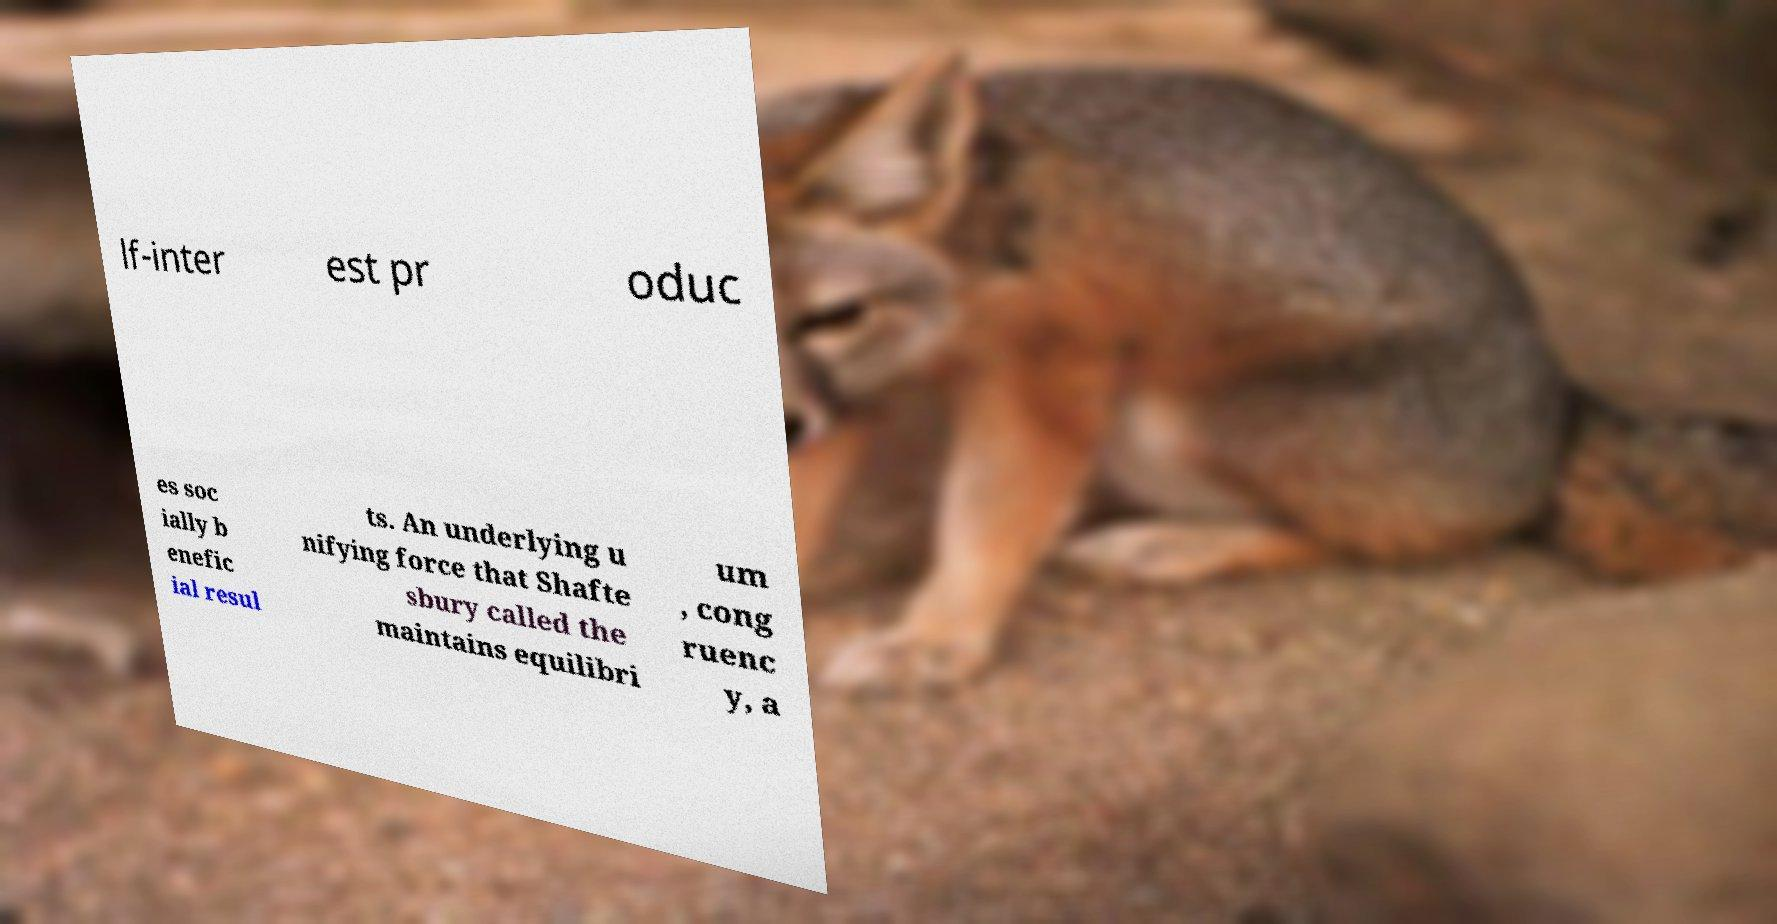There's text embedded in this image that I need extracted. Can you transcribe it verbatim? lf-inter est pr oduc es soc ially b enefic ial resul ts. An underlying u nifying force that Shafte sbury called the maintains equilibri um , cong ruenc y, a 